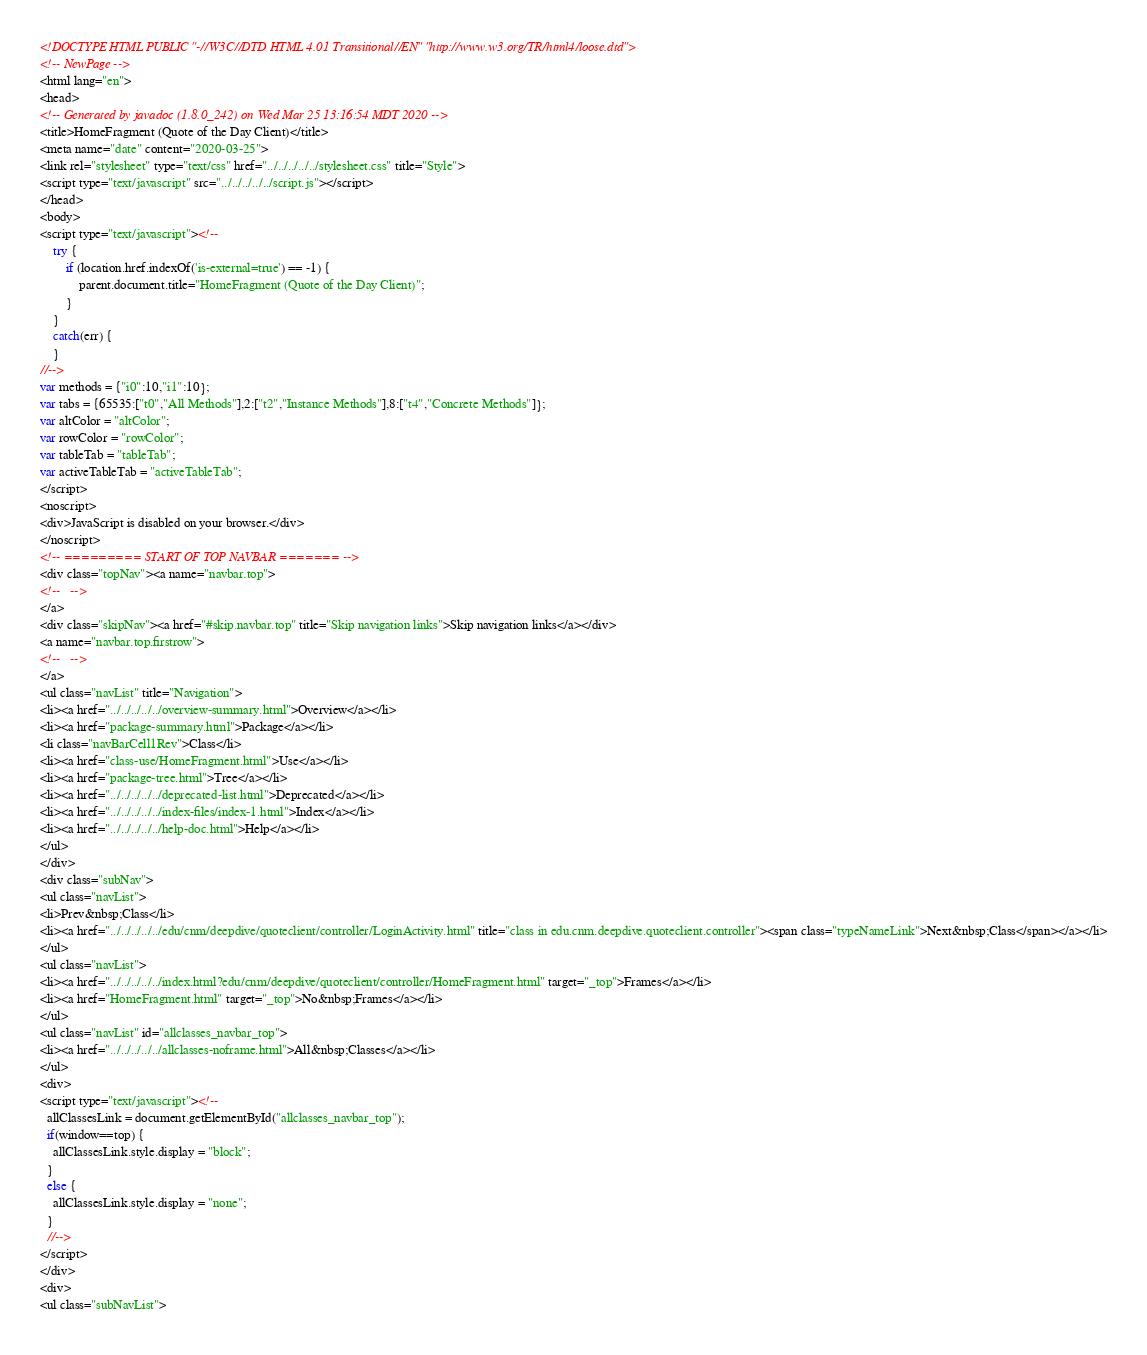<code> <loc_0><loc_0><loc_500><loc_500><_HTML_><!DOCTYPE HTML PUBLIC "-//W3C//DTD HTML 4.01 Transitional//EN" "http://www.w3.org/TR/html4/loose.dtd">
<!-- NewPage -->
<html lang="en">
<head>
<!-- Generated by javadoc (1.8.0_242) on Wed Mar 25 13:16:54 MDT 2020 -->
<title>HomeFragment (Quote of the Day Client)</title>
<meta name="date" content="2020-03-25">
<link rel="stylesheet" type="text/css" href="../../../../../stylesheet.css" title="Style">
<script type="text/javascript" src="../../../../../script.js"></script>
</head>
<body>
<script type="text/javascript"><!--
    try {
        if (location.href.indexOf('is-external=true') == -1) {
            parent.document.title="HomeFragment (Quote of the Day Client)";
        }
    }
    catch(err) {
    }
//-->
var methods = {"i0":10,"i1":10};
var tabs = {65535:["t0","All Methods"],2:["t2","Instance Methods"],8:["t4","Concrete Methods"]};
var altColor = "altColor";
var rowColor = "rowColor";
var tableTab = "tableTab";
var activeTableTab = "activeTableTab";
</script>
<noscript>
<div>JavaScript is disabled on your browser.</div>
</noscript>
<!-- ========= START OF TOP NAVBAR ======= -->
<div class="topNav"><a name="navbar.top">
<!--   -->
</a>
<div class="skipNav"><a href="#skip.navbar.top" title="Skip navigation links">Skip navigation links</a></div>
<a name="navbar.top.firstrow">
<!--   -->
</a>
<ul class="navList" title="Navigation">
<li><a href="../../../../../overview-summary.html">Overview</a></li>
<li><a href="package-summary.html">Package</a></li>
<li class="navBarCell1Rev">Class</li>
<li><a href="class-use/HomeFragment.html">Use</a></li>
<li><a href="package-tree.html">Tree</a></li>
<li><a href="../../../../../deprecated-list.html">Deprecated</a></li>
<li><a href="../../../../../index-files/index-1.html">Index</a></li>
<li><a href="../../../../../help-doc.html">Help</a></li>
</ul>
</div>
<div class="subNav">
<ul class="navList">
<li>Prev&nbsp;Class</li>
<li><a href="../../../../../edu/cnm/deepdive/quoteclient/controller/LoginActivity.html" title="class in edu.cnm.deepdive.quoteclient.controller"><span class="typeNameLink">Next&nbsp;Class</span></a></li>
</ul>
<ul class="navList">
<li><a href="../../../../../index.html?edu/cnm/deepdive/quoteclient/controller/HomeFragment.html" target="_top">Frames</a></li>
<li><a href="HomeFragment.html" target="_top">No&nbsp;Frames</a></li>
</ul>
<ul class="navList" id="allclasses_navbar_top">
<li><a href="../../../../../allclasses-noframe.html">All&nbsp;Classes</a></li>
</ul>
<div>
<script type="text/javascript"><!--
  allClassesLink = document.getElementById("allclasses_navbar_top");
  if(window==top) {
    allClassesLink.style.display = "block";
  }
  else {
    allClassesLink.style.display = "none";
  }
  //-->
</script>
</div>
<div>
<ul class="subNavList"></code> 